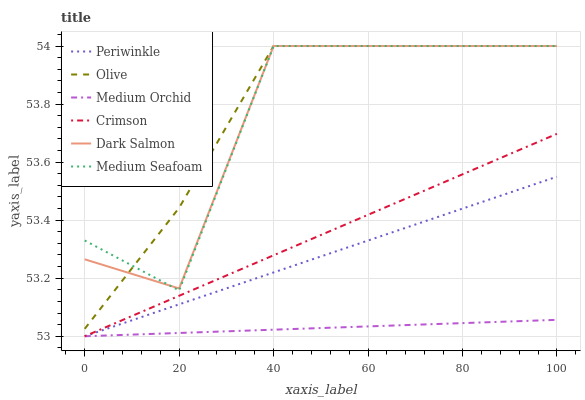Does Medium Orchid have the minimum area under the curve?
Answer yes or no. Yes. Does Olive have the maximum area under the curve?
Answer yes or no. Yes. Does Dark Salmon have the minimum area under the curve?
Answer yes or no. No. Does Dark Salmon have the maximum area under the curve?
Answer yes or no. No. Is Medium Orchid the smoothest?
Answer yes or no. Yes. Is Medium Seafoam the roughest?
Answer yes or no. Yes. Is Dark Salmon the smoothest?
Answer yes or no. No. Is Dark Salmon the roughest?
Answer yes or no. No. Does Medium Orchid have the lowest value?
Answer yes or no. Yes. Does Dark Salmon have the lowest value?
Answer yes or no. No. Does Medium Seafoam have the highest value?
Answer yes or no. Yes. Does Crimson have the highest value?
Answer yes or no. No. Is Medium Orchid less than Olive?
Answer yes or no. Yes. Is Olive greater than Medium Orchid?
Answer yes or no. Yes. Does Periwinkle intersect Medium Orchid?
Answer yes or no. Yes. Is Periwinkle less than Medium Orchid?
Answer yes or no. No. Is Periwinkle greater than Medium Orchid?
Answer yes or no. No. Does Medium Orchid intersect Olive?
Answer yes or no. No. 